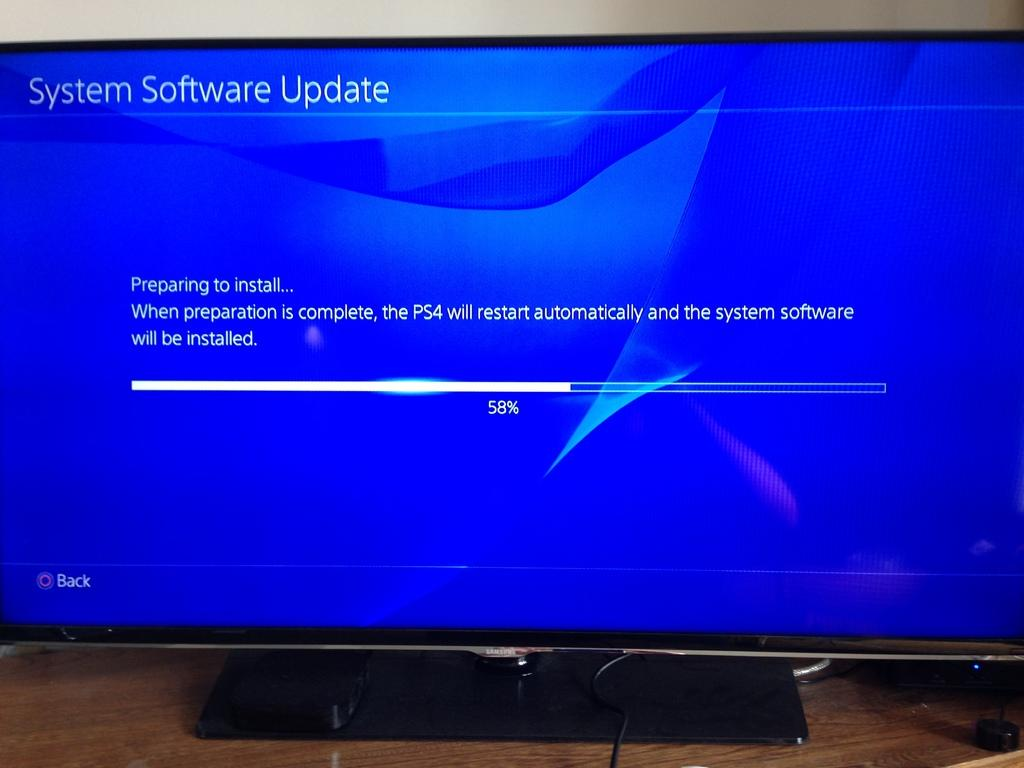What is the main object on the brown table in the image? There is a system on a brown color table in the image. What color is the screen of the system? The screen of the system is blue. What can be seen on the screen of the system? There is text on the screen. What is visible in the background of the image? There is a white wall in the background. Can you see any fish swimming near the system in the image? There are no fish present in the image. What type of needle is being used to interact with the system in the image? There is no needle present in the image; the system is likely being interacted with using a keyboard or mouse. 